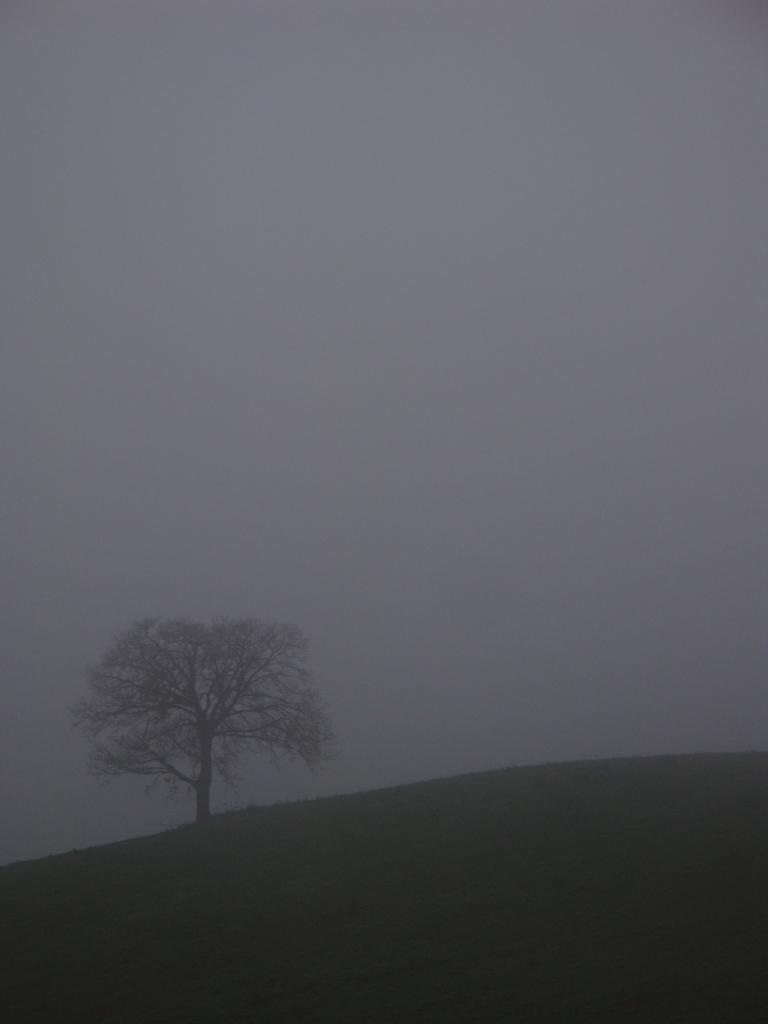What part of the natural environment can be seen in the image? The sky is visible in the image. What type of plant can be seen in the image? There is a tree in the image. What surface is visible beneath the sky and tree? The ground is visible in the image. How many grapes are hanging from the tree in the image? There are no grapes present in the image; it features a tree with no visible fruit. What type of toy is visible on the ground in the image? There is no toy present on the ground in the image; only the tree, sky, and ground are visible. 